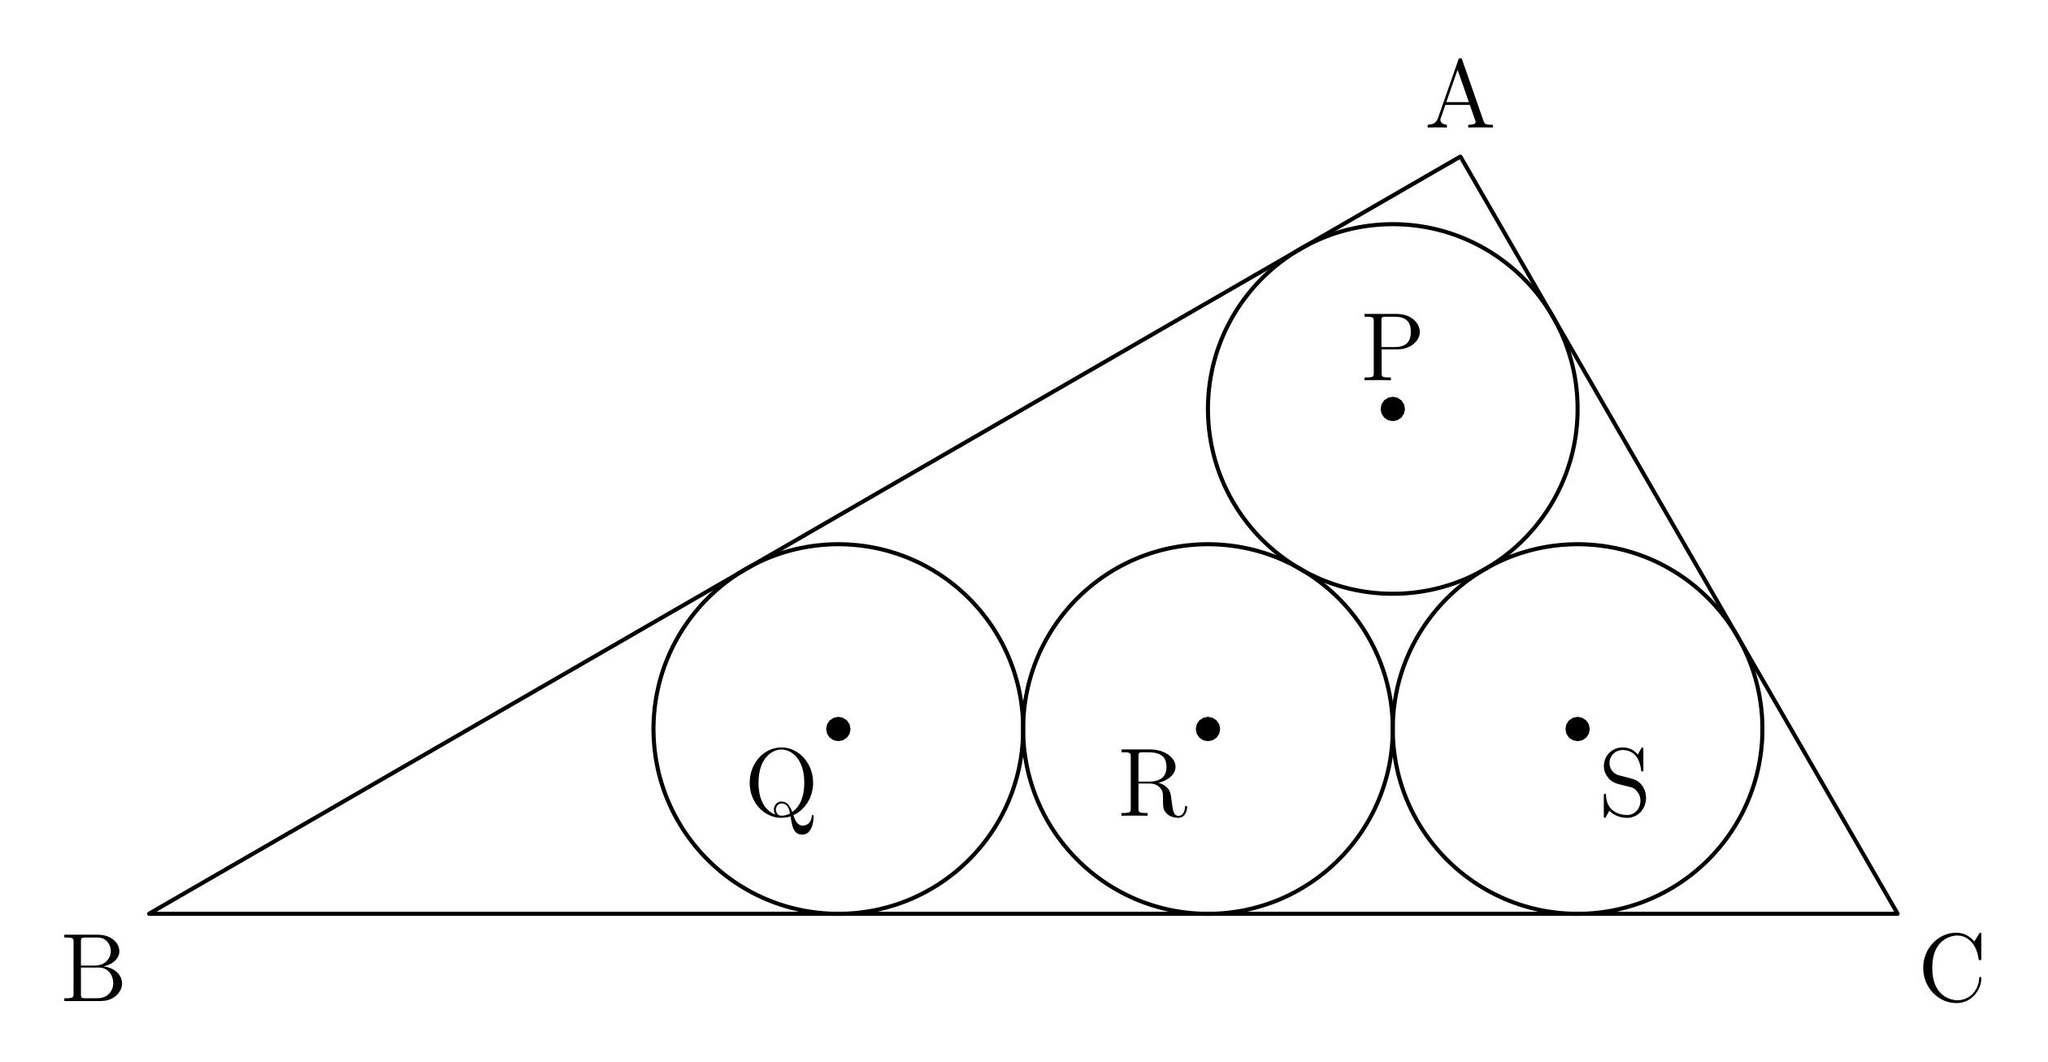In the diagram, four circles of radius 1 with centres $P$, $Q$, $R$, and $S$ are tangent to one another and to the sides of $\triangle ABC$, as shown. What is the degree measure of the smallest angle in triangle $PQS$? To determine the smallest angle in triangle $PQS$, we first need to consider the positioning and tangent nature of the circles within triangle $ABC$. Noticing that triangle $PQS$ must be isosceles (as the sides $PQ$ and $QS$ are equal, both being radii of adjacent tangent circles), and possibly equilateral if all angles were 60 degrees. To validate this, we'd apply specific geometric theorems or principles that fit this configuration, such as the Law of Cosines or by using angle chasing based on the properties of tangency and the known angles of triangle $ABC$. Unfortunately, without specific measures of angles of triangle $ABC$ itself, calculating the exact smallest angle in $PQS$ just from tangent circles configuration involves guesses or assumptions. If any angle in triangle $ABC$ is known or any side ratio, that could provide a definite path to solving the problem. 